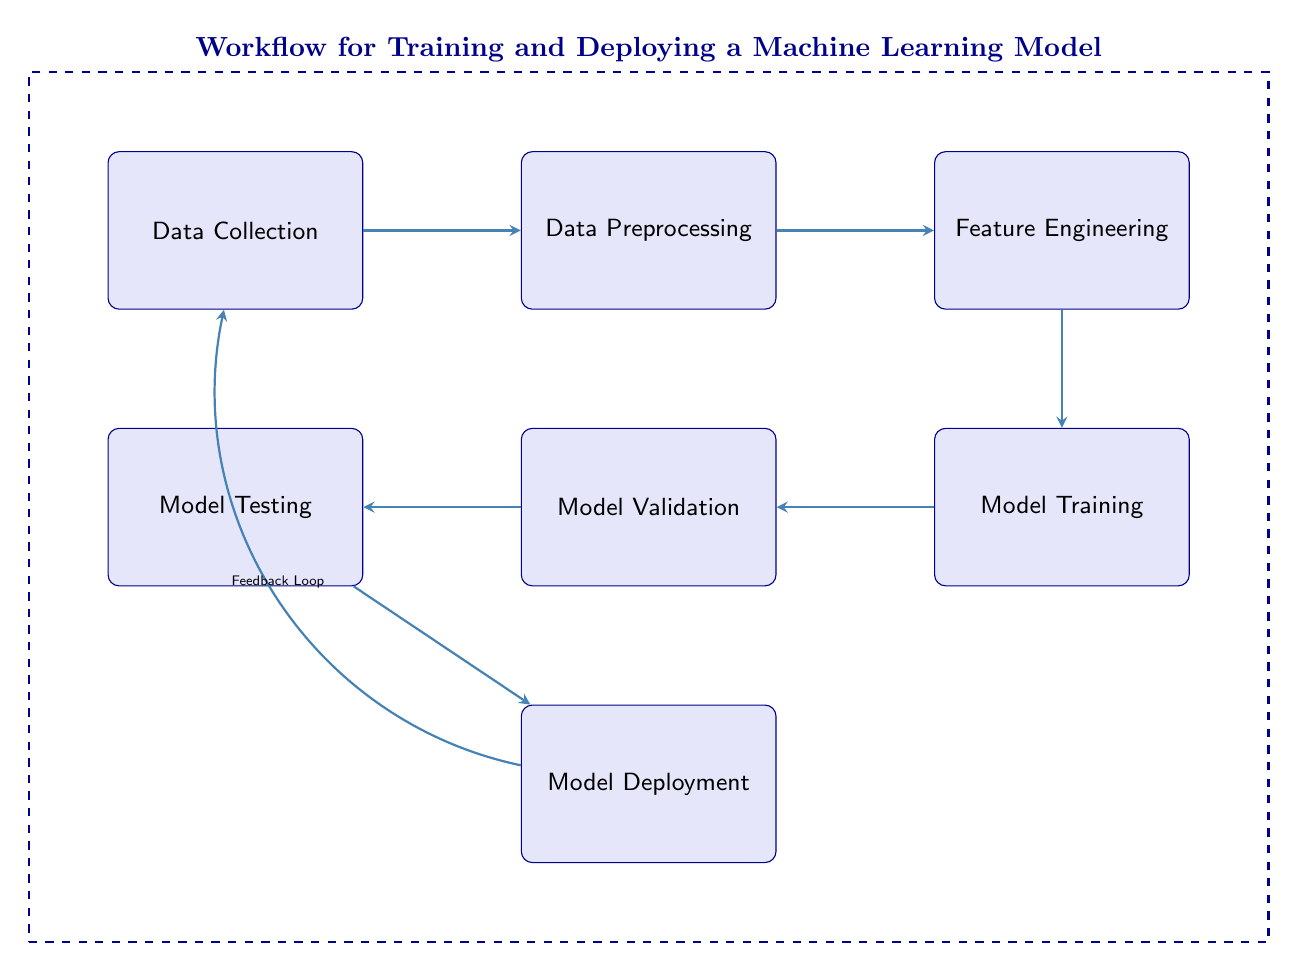What is the first step in the workflow? The diagram indicates that the process begins with "Data Collection," which is the first node in the flow. This is shown prominently at the top left of the diagram.
Answer: Data Collection How many nodes are present in the diagram? By counting all the distinct stages represented as nodes in the diagram, there are a total of six nodes: Data Collection, Data Preprocessing, Feature Engineering, Model Training, Model Validation, and Model Testing, and Model Deployment.
Answer: Six What follows Data Preprocessing in the workflow? The diagram shows an arrow leading directly from "Data Preprocessing" to "Feature Engineering," indicating that the next step after preprocessing is feature engineering.
Answer: Feature Engineering Which step is directly related to feedback? The diagram illustrates a feedback loop that connects "Model Deployment" back to "Data Collection," indicating that this step is directly related to the feedback process.
Answer: Data Collection In how many directions do the arrows flow in the diagram? Analyzing the arrows, there are six arrows that depict the flow from one stage to another and one additional arrow that represents the feedback loop, totaling seven arrows.
Answer: Seven What is the purpose of the feedback loop in this workflow? The feedback loop connects deployment to data collection, suggesting that after deployment, insights or information gathered might cause a revisit to the data collection stage to improve the model.
Answer: Improve model What is the last stage in the machine learning workflow depicted here? The diagram ends with the node labeled "Model Deployment," which is positioned at the bottom, signifying it's the concluding point of the workflow.
Answer: Model Deployment How is Model Validation connected to the rest of the workflow? The node "Model Validation" has an arrow leading from "Model Training" before pointing towards "Model Testing," indicating its sequential connection in the workflow.
Answer: Sequential connection Which two nodes are connected through a feedback loop? The feedback loop connects "Model Deployment" and "Data Collection," showcasing their relationship in the iterative process of improving the machine learning model.
Answer: Model Deployment and Data Collection 